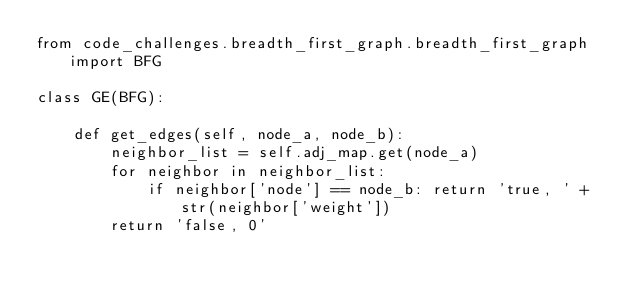<code> <loc_0><loc_0><loc_500><loc_500><_Python_>from code_challenges.breadth_first_graph.breadth_first_graph import BFG

class GE(BFG):

    def get_edges(self, node_a, node_b):
        neighbor_list = self.adj_map.get(node_a)
        for neighbor in neighbor_list:
            if neighbor['node'] == node_b: return 'true, ' + str(neighbor['weight'])
        return 'false, 0'
</code> 